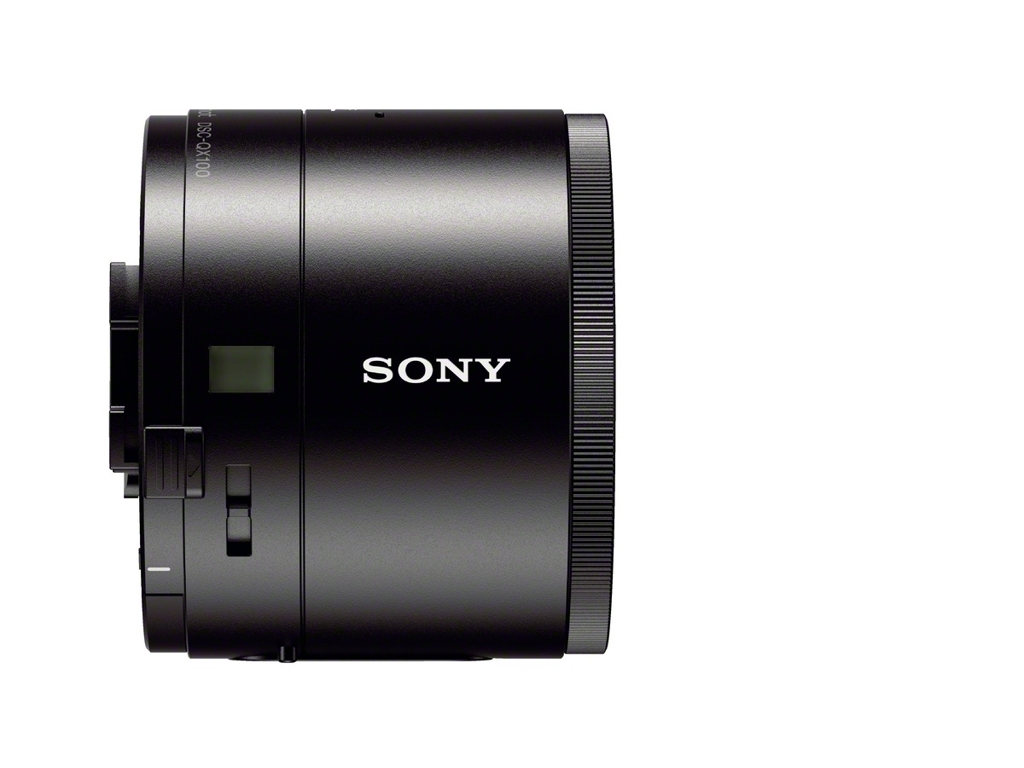Can you describe the design aesthetic of this item? The lens sports a sleek, modern design with a matte black finish and minimalistic branding. It portrays a professional look that aligns with the visual style commonly seen in high-end camera equipment. 